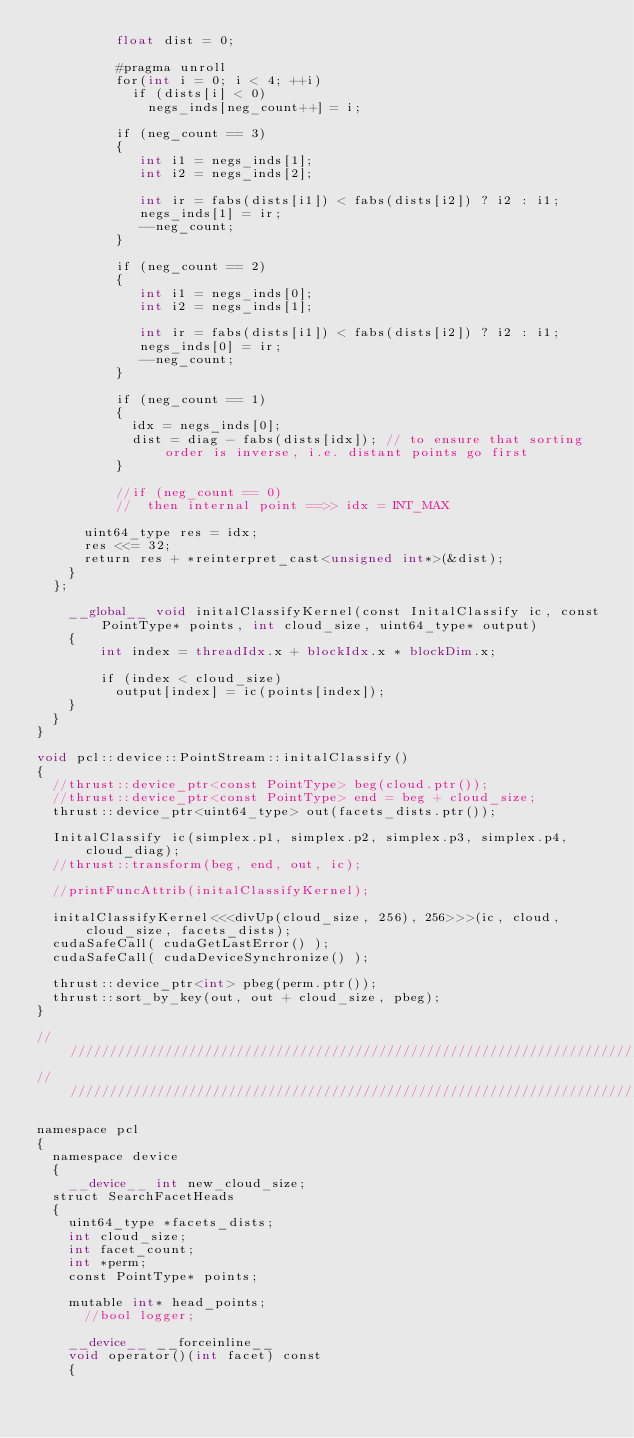<code> <loc_0><loc_0><loc_500><loc_500><_Cuda_>          float dist = 0;

          #pragma unroll
          for(int i = 0; i < 4; ++i)
            if (dists[i] < 0)
              negs_inds[neg_count++] = i;

          if (neg_count == 3)
          {
             int i1 = negs_inds[1];
             int i2 = negs_inds[2];
             
             int ir = fabs(dists[i1]) < fabs(dists[i2]) ? i2 : i1;
             negs_inds[1] = ir;
             --neg_count;
          }

          if (neg_count == 2)
          {
             int i1 = negs_inds[0];
             int i2 = negs_inds[1];
             
             int ir = fabs(dists[i1]) < fabs(dists[i2]) ? i2 : i1;
             negs_inds[0] = ir;
             --neg_count;              
          }

          if (neg_count == 1)
          {
            idx = negs_inds[0];
            dist = diag - fabs(dists[idx]); // to ensure that sorting order is inverse, i.e. distant points go first
          }

          //if (neg_count == 0)
          //  then internal point ==>> idx = INT_MAX

		  uint64_type res = idx;
		  res <<= 32;
		  return res + *reinterpret_cast<unsigned int*>(&dist);
	  }		
	};		

    __global__ void initalClassifyKernel(const InitalClassify ic, const PointType* points, int cloud_size, uint64_type* output) 
    { 
        int index = threadIdx.x + blockIdx.x * blockDim.x;

        if (index < cloud_size)              
          output[index] = ic(points[index]); 
    }
  }
}

void pcl::device::PointStream::initalClassify()
{        
  //thrust::device_ptr<const PointType> beg(cloud.ptr());
  //thrust::device_ptr<const PointType> end = beg + cloud_size;
  thrust::device_ptr<uint64_type> out(facets_dists.ptr());
  
  InitalClassify ic(simplex.p1, simplex.p2, simplex.p3, simplex.p4, cloud_diag);
  //thrust::transform(beg, end, out, ic);
  
  //printFuncAttrib(initalClassifyKernel);

  initalClassifyKernel<<<divUp(cloud_size, 256), 256>>>(ic, cloud, cloud_size, facets_dists);
  cudaSafeCall( cudaGetLastError() );
  cudaSafeCall( cudaDeviceSynchronize() );

  thrust::device_ptr<int> pbeg(perm.ptr());
  thrust::sort_by_key(out, out + cloud_size, pbeg);
}

///////////////////////////////////////////////////////////////////////////////////
///////////////////////////////////////////////////////////////////////////////////

namespace pcl
{
  namespace device
  {
    __device__ int new_cloud_size;    
	struct SearchFacetHeads
	{		
	  uint64_type *facets_dists;
	  int cloud_size;
	  int facet_count;
	  int *perm;
	  const PointType* points;

	  mutable int* head_points;
      //bool logger;
	
	  __device__ __forceinline__
	  void operator()(int facet) const
	  {			</code> 